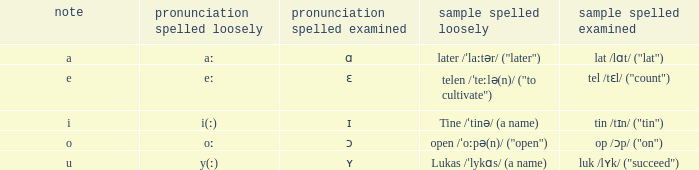What is Pronunciation Spelled Free, when Pronunciation Spelled Checked is "ɑ"? Aː. 